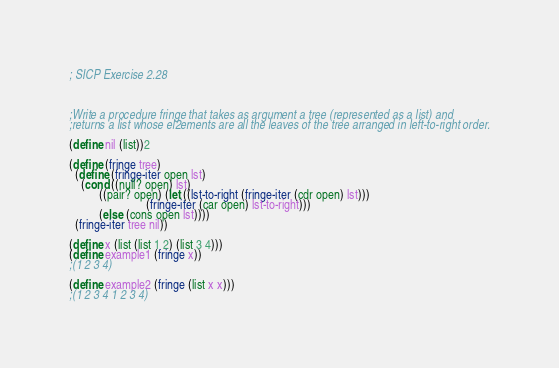Convert code to text. <code><loc_0><loc_0><loc_500><loc_500><_Scheme_>; SICP Exercise 2.28



;Write a procedure fringe that takes as argument a tree (represented as a list) and
;returns a list whose el2ements are all the leaves of the tree arranged in left-to-right order.

(define nil (list))2

(define (fringe tree)
  (define (fringe-iter open lst)
    (cond ((null? open) lst)
          ((pair? open) (let ((lst-to-right (fringe-iter (cdr open) lst)))
                          (fringe-iter (car open) lst-to-right)))
          (else (cons open lst))))
  (fringe-iter tree nil))

(define x (list (list 1 2) (list 3 4)))
(define example1 (fringe x))
;(1 2 3 4)

(define example2 (fringe (list x x)))
;(1 2 3 4 1 2 3 4)
</code> 